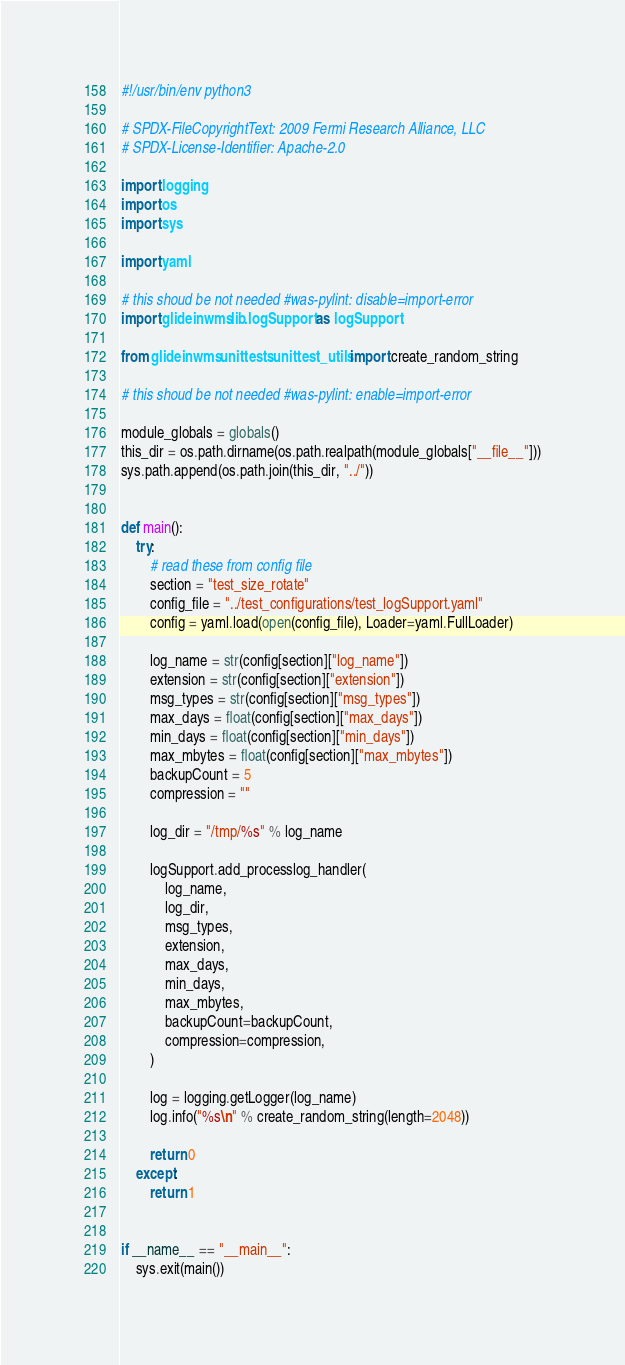<code> <loc_0><loc_0><loc_500><loc_500><_Python_>#!/usr/bin/env python3

# SPDX-FileCopyrightText: 2009 Fermi Research Alliance, LLC
# SPDX-License-Identifier: Apache-2.0

import logging
import os
import sys

import yaml

# this shoud be not needed #was-pylint: disable=import-error
import glideinwms.lib.logSupport as logSupport

from glideinwms.unittests.unittest_utils import create_random_string

# this shoud be not needed #was-pylint: enable=import-error

module_globals = globals()
this_dir = os.path.dirname(os.path.realpath(module_globals["__file__"]))
sys.path.append(os.path.join(this_dir, "../"))


def main():
    try:
        # read these from config file
        section = "test_size_rotate"
        config_file = "../test_configurations/test_logSupport.yaml"
        config = yaml.load(open(config_file), Loader=yaml.FullLoader)

        log_name = str(config[section]["log_name"])
        extension = str(config[section]["extension"])
        msg_types = str(config[section]["msg_types"])
        max_days = float(config[section]["max_days"])
        min_days = float(config[section]["min_days"])
        max_mbytes = float(config[section]["max_mbytes"])
        backupCount = 5
        compression = ""

        log_dir = "/tmp/%s" % log_name

        logSupport.add_processlog_handler(
            log_name,
            log_dir,
            msg_types,
            extension,
            max_days,
            min_days,
            max_mbytes,
            backupCount=backupCount,
            compression=compression,
        )

        log = logging.getLogger(log_name)
        log.info("%s\n" % create_random_string(length=2048))

        return 0
    except:
        return 1


if __name__ == "__main__":
    sys.exit(main())
</code> 